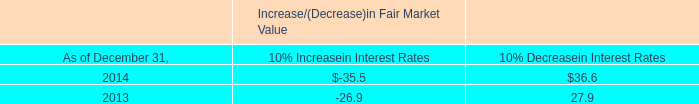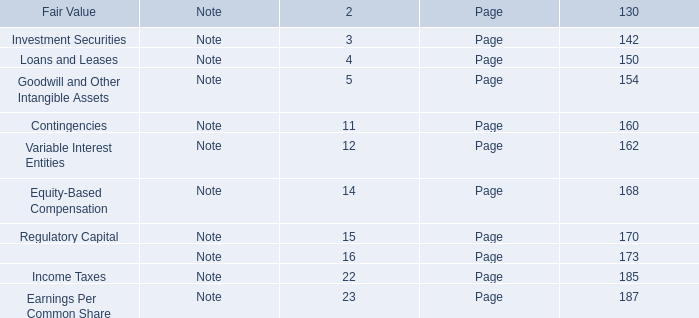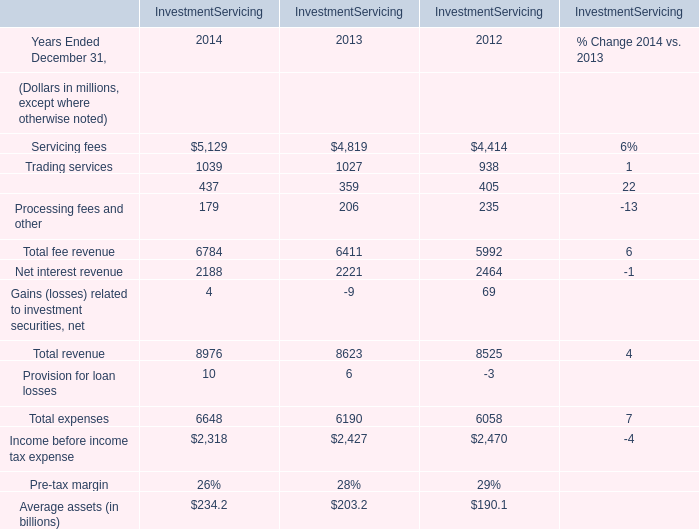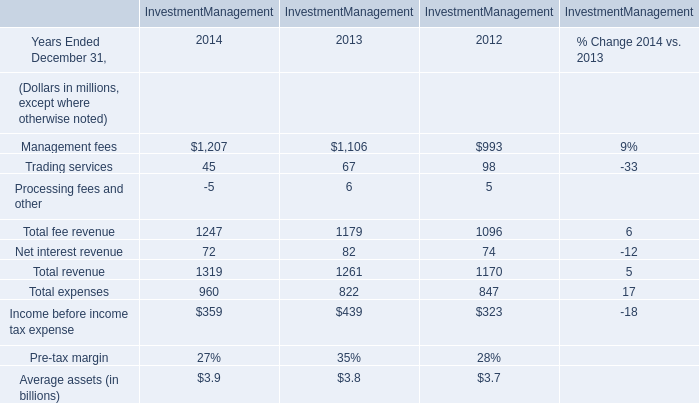What's the increasing rate of Total fee revenue for Investment Management in 2013 Ended December 31? 
Computations: ((1179 - 1096) / 1096)
Answer: 0.07573. 